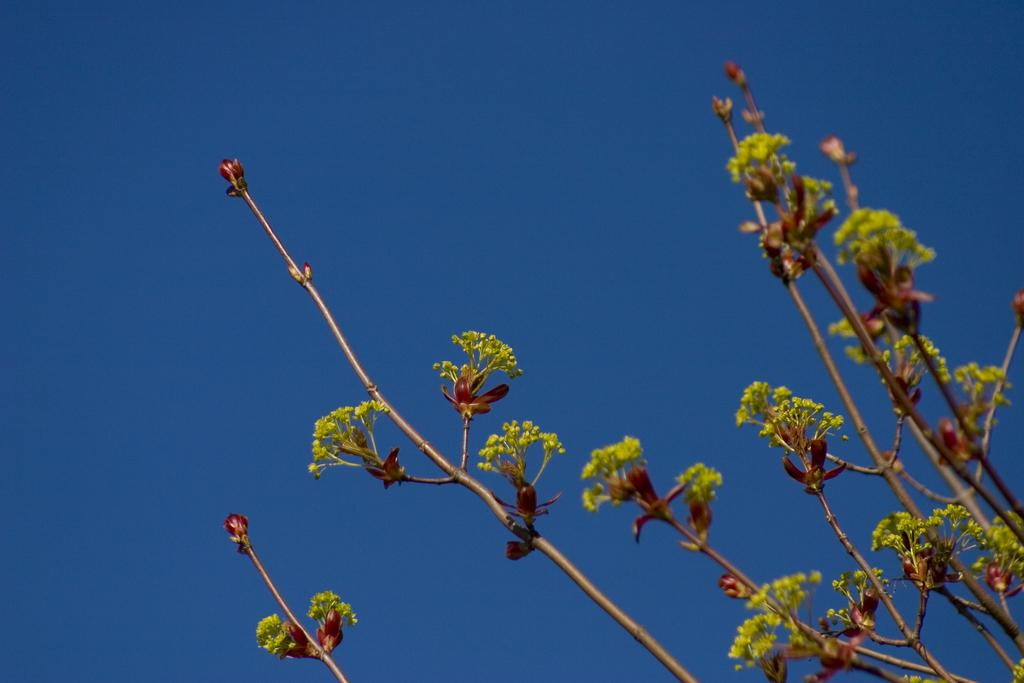What type of plant elements are visible in the image? The image contains stems of a tree. Are there any additional elements related to the tree visible in the image? Yes, there are flowers in the image. What is the condition of the sky in the image? The sky is clear in the image. What is the weather like in the image? It is sunny in the image. Can you see any matches being used to light the flowers in the image? There are no matches or any indication of fire in the image; it features stems of a tree and flowers. Is there a ladybug visible on any of the tree stems in the image? There is no ladybug present in the image. 